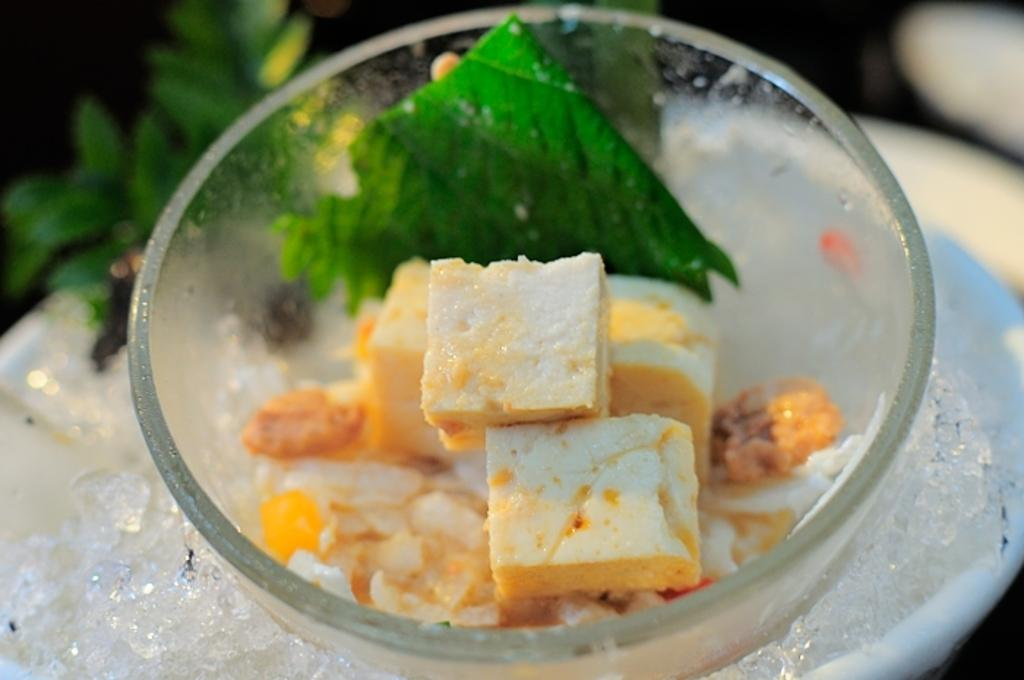What is the main food item featured in the image? There is a cake in the image. What other items can be seen in the image besides the cake? There is a green color leaf in a bowl and ice in a white color bowl. What type of fruit is causing fear in the image? There is no fruit present in the image, nor is there any indication of fear. 